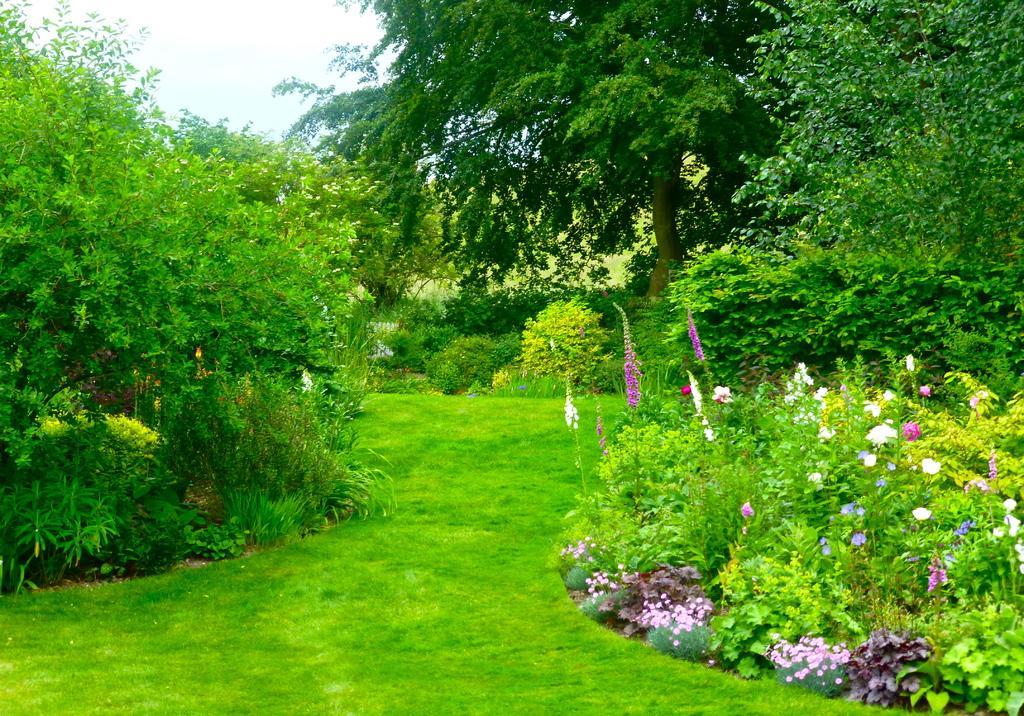How would you summarize this image in a sentence or two? In this image on the right side and left side there are some plants, flowers and trees. At the bottom there is grass, in the background also there are some trees and sky. 